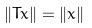<formula> <loc_0><loc_0><loc_500><loc_500>\| T x \| = \| x \|</formula> 